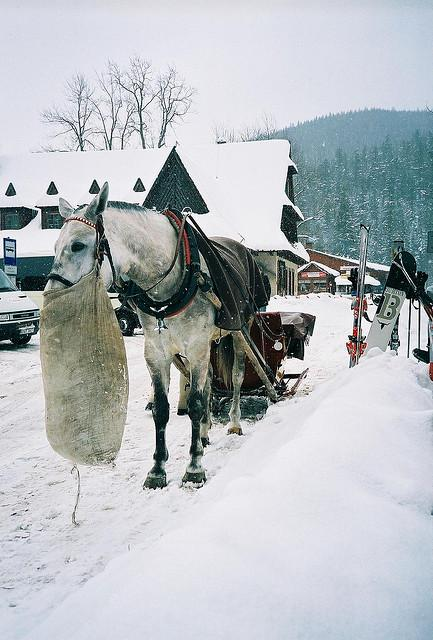The animal has how many legs?

Choices:
A) four
B) eight
C) six
D) two four 